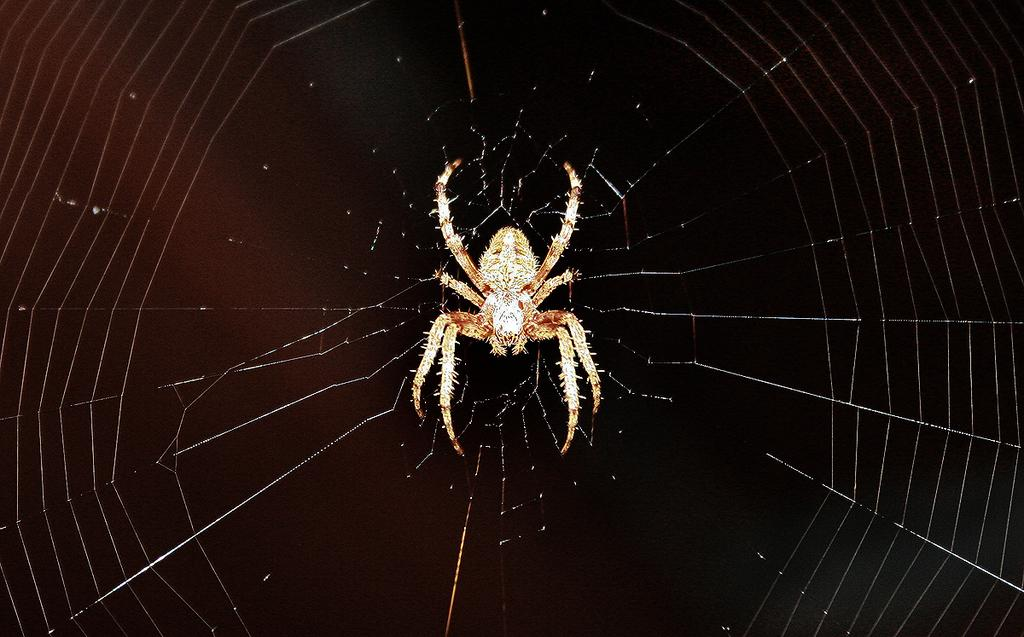What is the main subject of the image? The main subject of the image is a spider. What is the spider associated with in the image? There is a spider web in the image. What can be observed about the overall appearance of the image? The background of the image is dark. Can you see the maid cleaning the airport in the image? There is no maid or airport present in the image; it features a spider and a spider web. What type of face can be seen on the spider in the image? Spiders do not have faces like humans or animals, so there is no face visible on the spider in the image. 